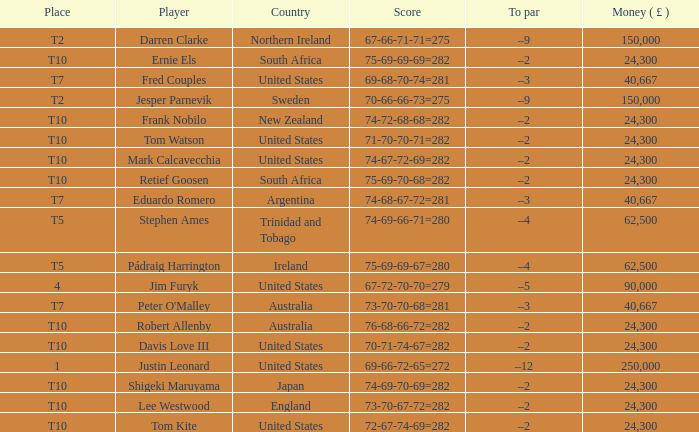What is Lee Westwood's score? 73-70-67-72=282. 